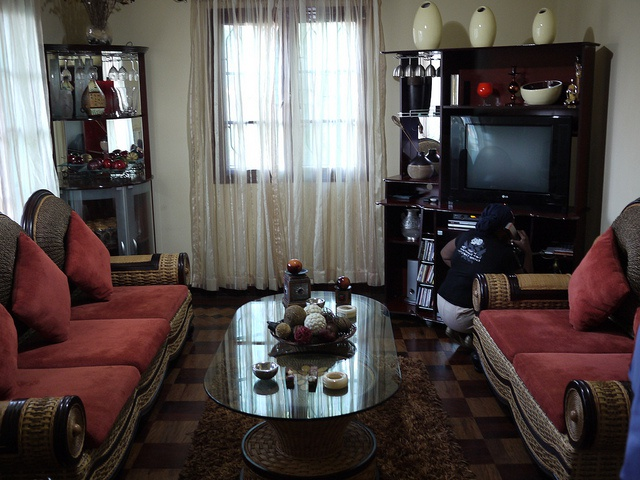Describe the objects in this image and their specific colors. I can see couch in gray, maroon, and black tones, dining table in gray, black, darkgray, and lightblue tones, couch in gray, maroon, and black tones, tv in gray, black, blue, and darkblue tones, and people in gray, black, darkgray, and navy tones in this image. 